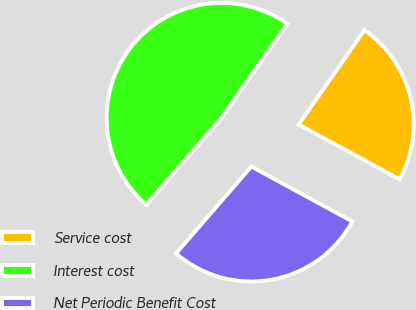<chart> <loc_0><loc_0><loc_500><loc_500><pie_chart><fcel>Service cost<fcel>Interest cost<fcel>Net Periodic Benefit Cost<nl><fcel>23.22%<fcel>48.34%<fcel>28.44%<nl></chart> 